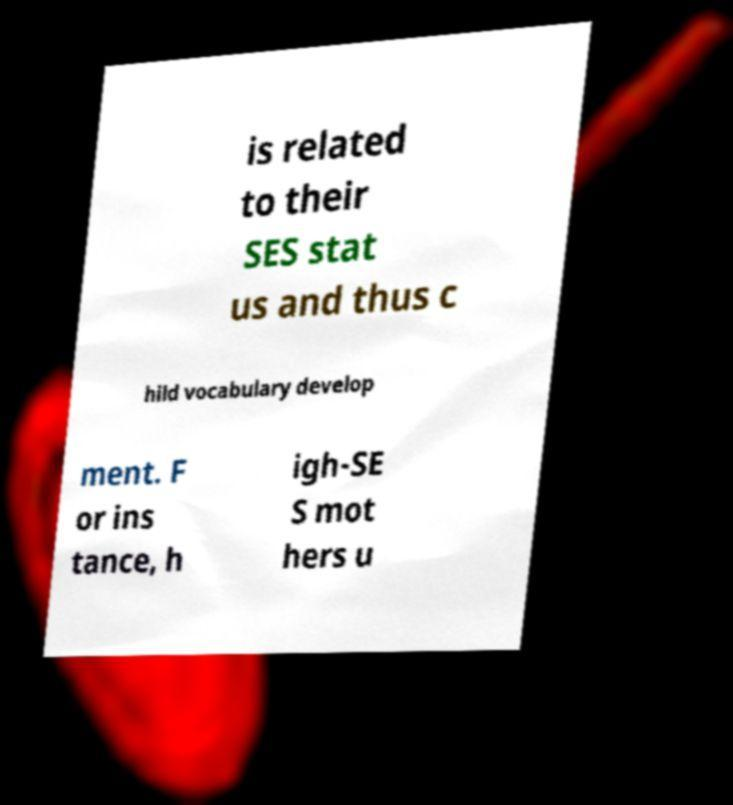Please read and relay the text visible in this image. What does it say? is related to their SES stat us and thus c hild vocabulary develop ment. F or ins tance, h igh-SE S mot hers u 